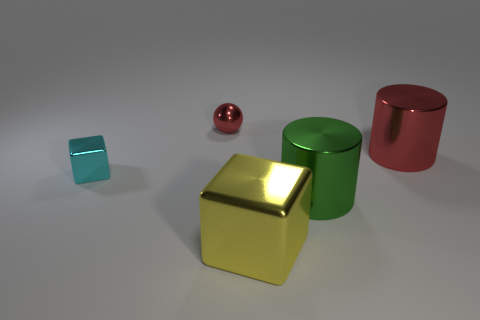The cylinder that is the same color as the metallic sphere is what size?
Keep it short and to the point. Large. What color is the cube that is the same size as the red metal cylinder?
Your answer should be compact. Yellow. What number of other things are the same shape as the yellow object?
Give a very brief answer. 1. Do the yellow metallic object and the metal sphere that is to the right of the cyan shiny thing have the same size?
Your answer should be very brief. No. What number of things are big yellow metal balls or red things?
Your response must be concise. 2. How many other things are there of the same size as the yellow metallic thing?
Your response must be concise. 2. There is a small shiny block; is it the same color as the metallic block that is in front of the small cyan block?
Ensure brevity in your answer.  No. How many cylinders are cyan things or small metallic objects?
Your answer should be very brief. 0. Is there anything else that has the same color as the small cube?
Offer a terse response. No. What is the material of the thing behind the large metallic cylinder that is behind the tiny cyan metallic block?
Offer a terse response. Metal. 